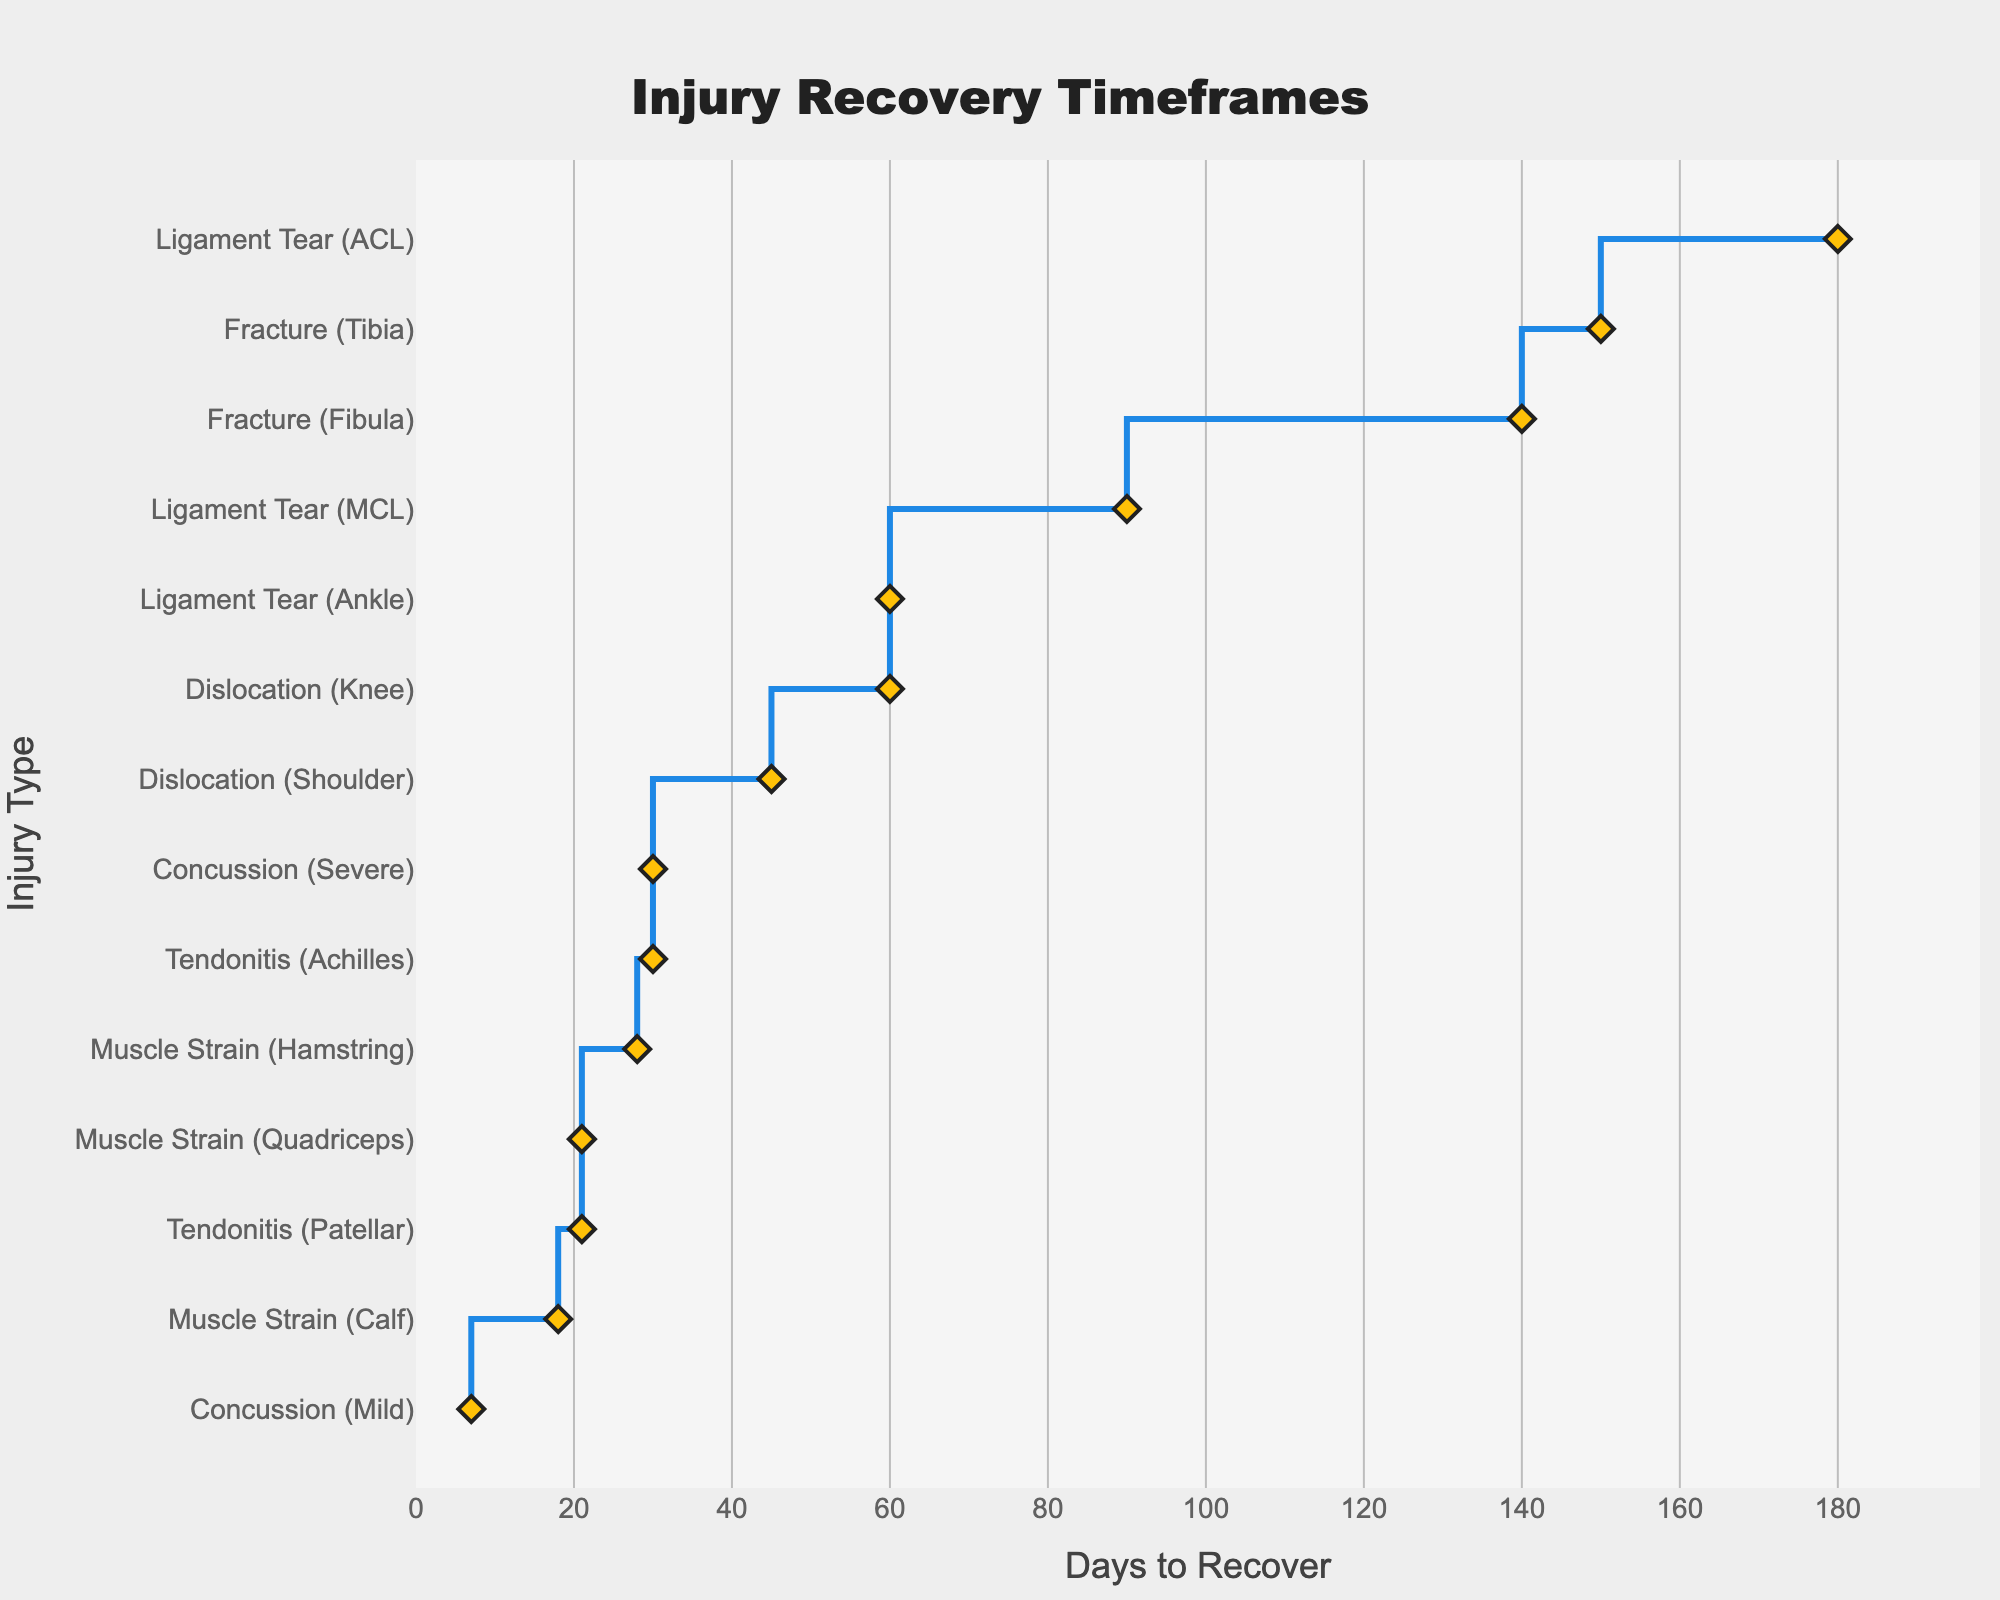How many injury types are represented on the plot? The plot shows different injury types on the y-axis. By counting each unique entry, we can determine the number of distinct injury types.
Answer: 14 What is the title of the stair plot? The title is usually placed at the top of the plot and often larger and bolder than other text. By looking at this area, we can determine the title.
Answer: Injury Recovery Timeframes Which type of injury has the longest recovery time? By observing the x-axis, which shows recovery days, the injury type at the extreme right of the plot represents the longest recovery time.
Answer: Ligament Tear (ACL) How many injury types have a recovery time of 60 days? Identifying the recovery days at 60 on the x-axis and noting the connected injury types in the y-axis will give the count. Two injuries, "Ligament Tear (Ankle)" and "Dislocation (Knee)", fall in this category.
Answer: 2 What is the recovery time difference between a Tibia fracture and a Fibula fracture? Select the recovery times for both injuries from the axis and compute the difference: Tibia (150 days) minus Fibula (140 days).
Answer: 10 days Which injury has a shorter recovery time, Muscle Strain (Hamstring) or Muscle Strain (Calf)? Compare the positions of Muscle Strain (Hamstring) and Muscle Strain (Calf) along the x-axis, noting which is on the left (indicating a shorter recovery).
Answer: Muscle Strain (Calf) What is the median recovery period of all the injuries listed? Arrange the recovery days in ascending order: 7, 18, 21, 21, 28, 30, 30, 45, 60, 60, 90, 140, 150, 180. As there are 14 entries, the median is the average of the 7th and 8th values, i.e., (30+45)/2.
Answer: 37.5 days How do the recovery periods for concussions differ based on severity? Locate both Mild and Severe Concussion recovery periods. Mild Concussion = 7 days and Severe Concussion = 30 days. Compute the difference by subtraction.
Answer: 23 days Which injury type overlaps the recovery time with a knee dislocation? Note the position of Knee Dislocation (60 days) and identify all other injuries sharing the same position on the x-axis.
Answer: Ligament Tear (Ankle) What's the total time needed for recovery if a player suffers from Tendonitis (Achilles) and a Quadriceps Muscle Strain simultaneously? Add the recovery days for Tendonitis (Achilles) and Muscle Strain (Quadriceps). Tendonitis (Achilles) is 30 days, and Muscle Strain (Quadriceps) is 21 days; thus, 30 + 21.
Answer: 51 days 